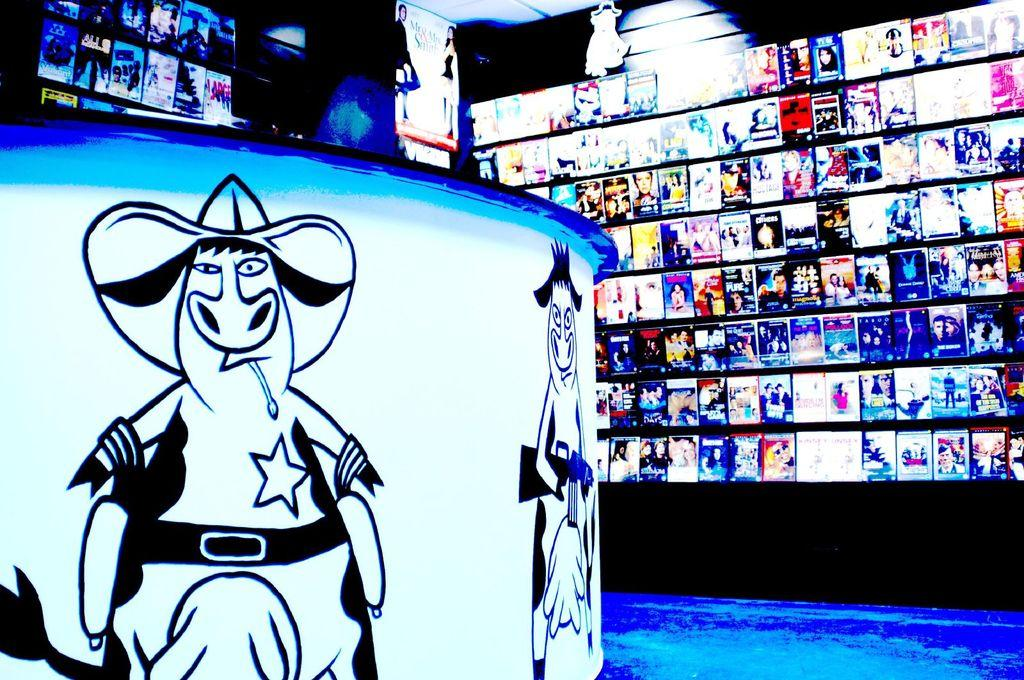What structure is located on the left side of the image? There is a table on the left side of the image. What is placed on the table in the image? There are paintings on the table. What can be seen on the wall in the background of the image? There are posters on the wall in the background. What is visible in the background of the image? There is a light visible in the background. What type of weather can be seen in the image? There is no weather depicted in the image; it is an indoor scene with a table, paintings, posters, and a light. What button is being pressed by the representative in the image? There is no representative or button present in the image. 